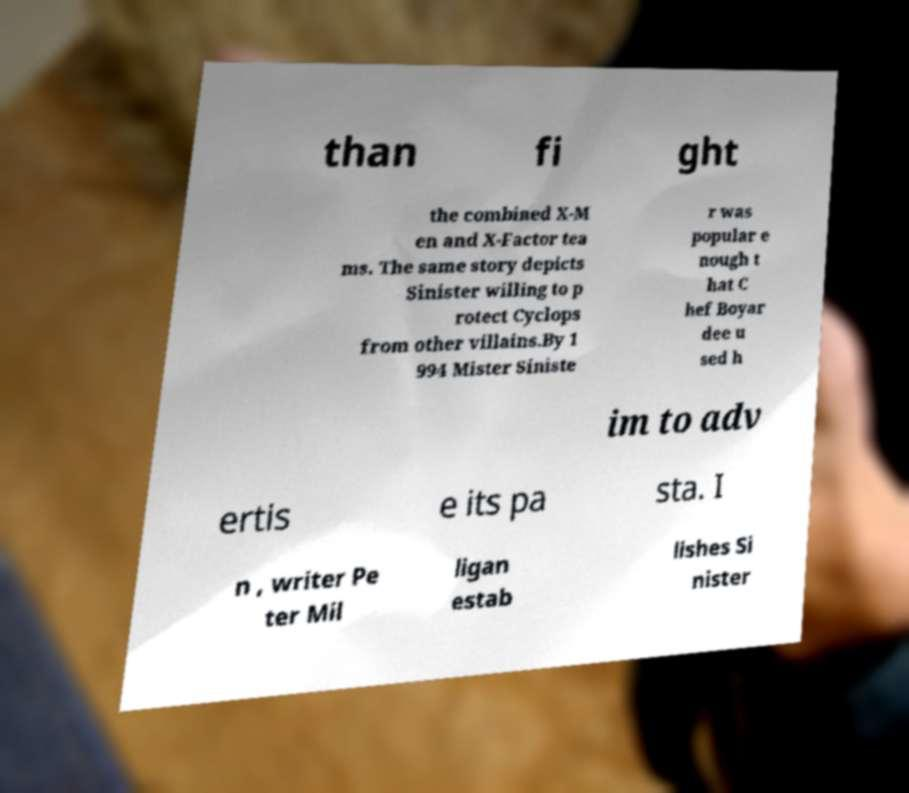Can you read and provide the text displayed in the image?This photo seems to have some interesting text. Can you extract and type it out for me? than fi ght the combined X-M en and X-Factor tea ms. The same story depicts Sinister willing to p rotect Cyclops from other villains.By 1 994 Mister Siniste r was popular e nough t hat C hef Boyar dee u sed h im to adv ertis e its pa sta. I n , writer Pe ter Mil ligan estab lishes Si nister 